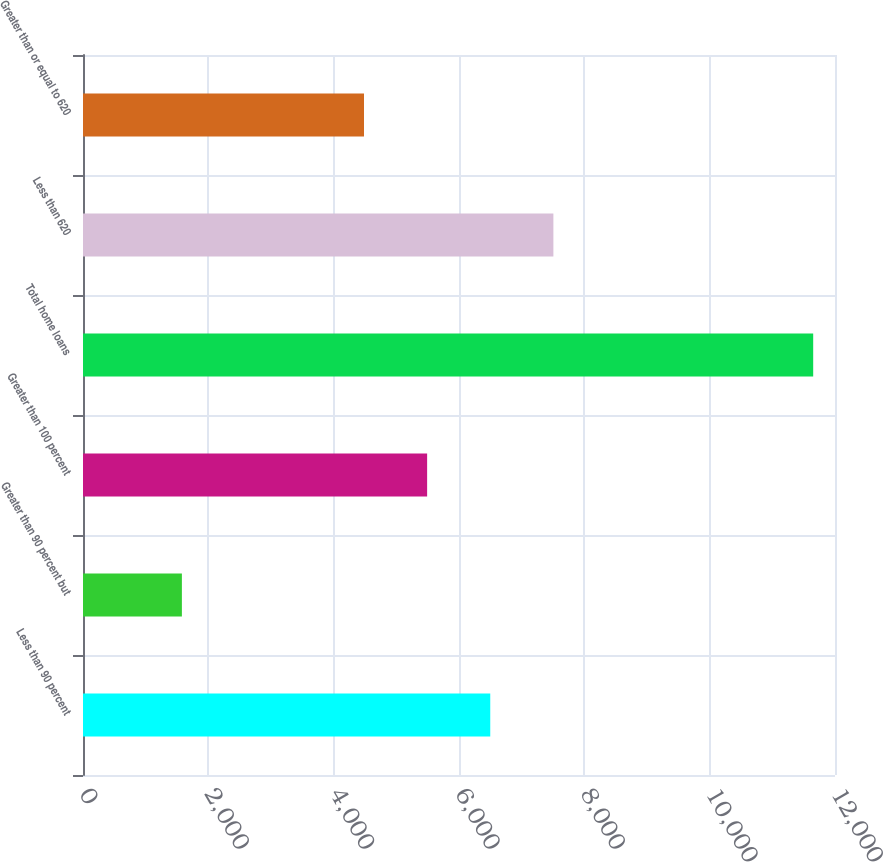Convert chart to OTSL. <chart><loc_0><loc_0><loc_500><loc_500><bar_chart><fcel>Less than 90 percent<fcel>Greater than 90 percent but<fcel>Greater than 100 percent<fcel>Total home loans<fcel>Less than 620<fcel>Greater than or equal to 620<nl><fcel>6498.8<fcel>1578<fcel>5491.4<fcel>11652<fcel>7506.2<fcel>4484<nl></chart> 